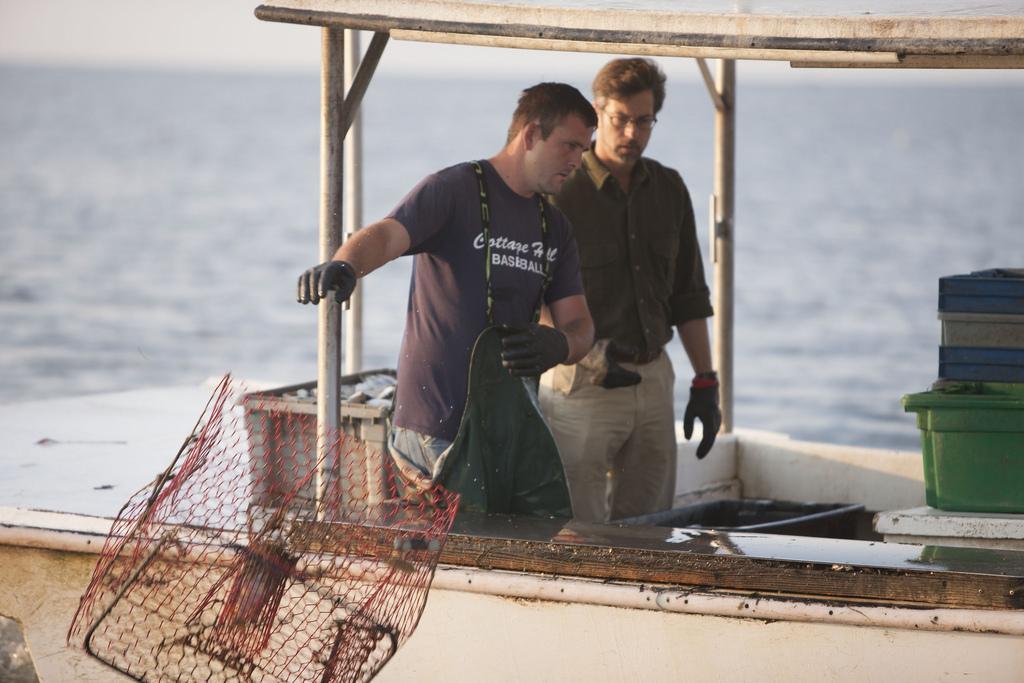Describe this image in one or two sentences. In this image there is a boat in the water. On the boat there are two persons. There is a net and there are tubs. 